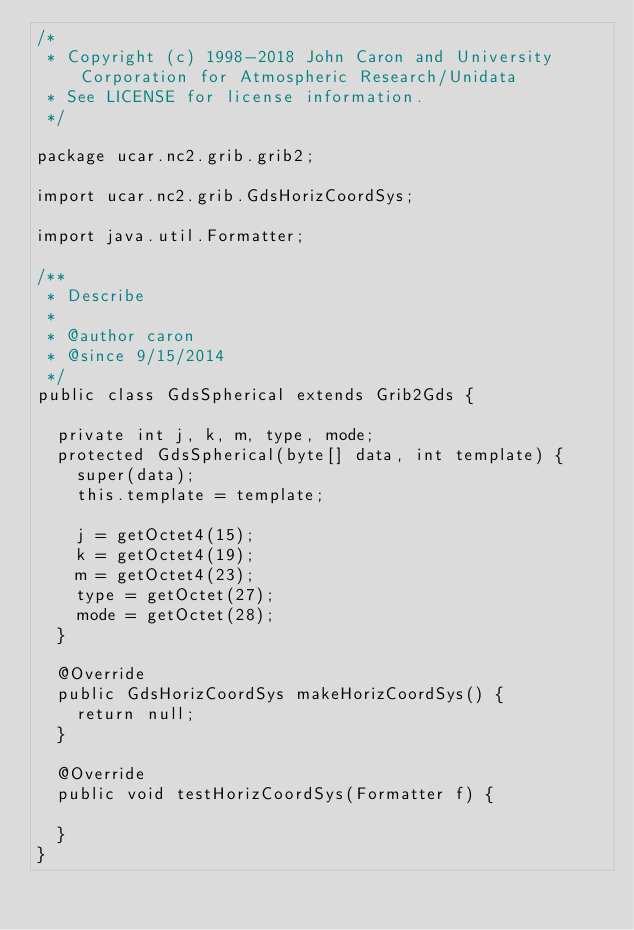Convert code to text. <code><loc_0><loc_0><loc_500><loc_500><_Java_>/*
 * Copyright (c) 1998-2018 John Caron and University Corporation for Atmospheric Research/Unidata
 * See LICENSE for license information.
 */

package ucar.nc2.grib.grib2;

import ucar.nc2.grib.GdsHorizCoordSys;

import java.util.Formatter;

/**
 * Describe
 *
 * @author caron
 * @since 9/15/2014
 */
public class GdsSpherical extends Grib2Gds {

  private int j, k, m, type, mode;
  protected GdsSpherical(byte[] data, int template) {
    super(data);
    this.template = template;

    j = getOctet4(15);
    k = getOctet4(19);
    m = getOctet4(23);
    type = getOctet(27);
    mode = getOctet(28);
  }

  @Override
  public GdsHorizCoordSys makeHorizCoordSys() {
    return null;
  }

  @Override
  public void testHorizCoordSys(Formatter f) {

  }
}
</code> 